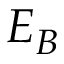Convert formula to latex. <formula><loc_0><loc_0><loc_500><loc_500>E _ { B }</formula> 